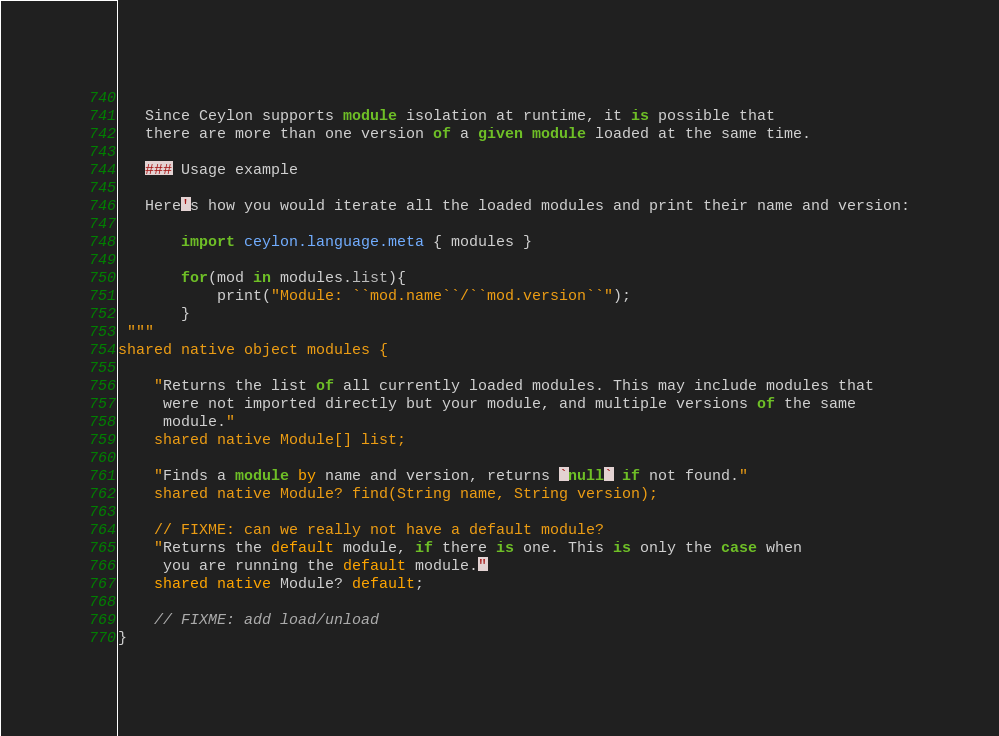<code> <loc_0><loc_0><loc_500><loc_500><_Ceylon_>   
   Since Ceylon supports module isolation at runtime, it is possible that
   there are more than one version of a given module loaded at the same time.
   
   ### Usage example
   
   Here's how you would iterate all the loaded modules and print their name and version:
   
       import ceylon.language.meta { modules }
   
       for(mod in modules.list){
           print("Module: ``mod.name``/``mod.version``");
       }
 """
shared native object modules {
    
    "Returns the list of all currently loaded modules. This may include modules that
     were not imported directly but your module, and multiple versions of the same
     module."
    shared native Module[] list;
    
    "Finds a module by name and version, returns `null` if not found."
    shared native Module? find(String name, String version);
    
    // FIXME: can we really not have a default module?
    "Returns the default module, if there is one. This is only the case when
     you are running the default module."
    shared native Module? default;
    
    // FIXME: add load/unload
}</code> 